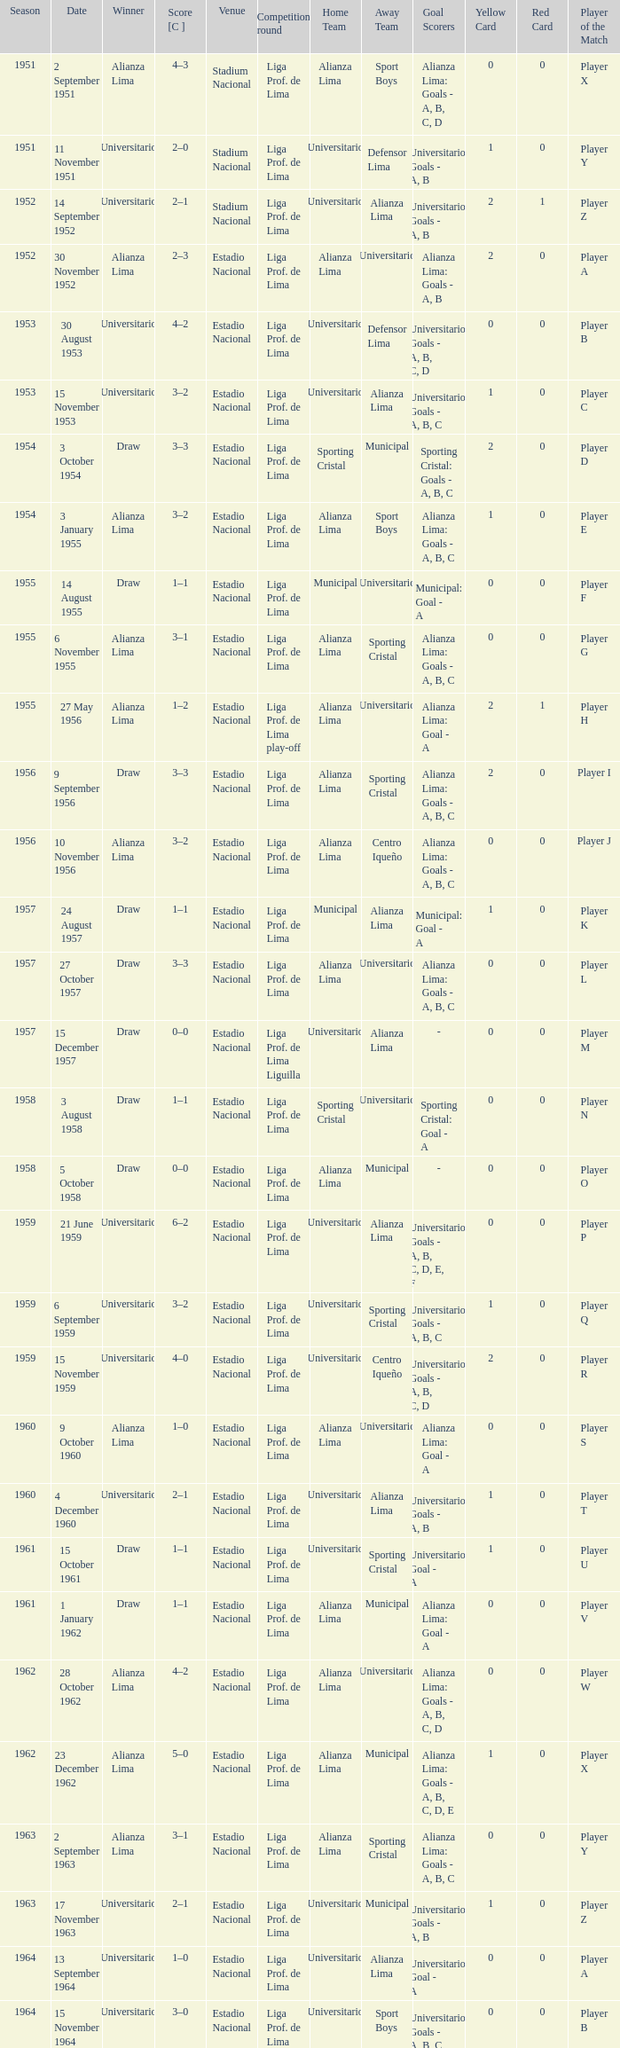What is the most recent season with a date of 27 October 1957? 1957.0. 